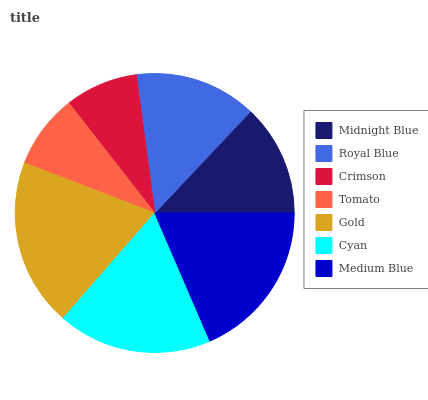Is Crimson the minimum?
Answer yes or no. Yes. Is Gold the maximum?
Answer yes or no. Yes. Is Royal Blue the minimum?
Answer yes or no. No. Is Royal Blue the maximum?
Answer yes or no. No. Is Royal Blue greater than Midnight Blue?
Answer yes or no. Yes. Is Midnight Blue less than Royal Blue?
Answer yes or no. Yes. Is Midnight Blue greater than Royal Blue?
Answer yes or no. No. Is Royal Blue less than Midnight Blue?
Answer yes or no. No. Is Royal Blue the high median?
Answer yes or no. Yes. Is Royal Blue the low median?
Answer yes or no. Yes. Is Medium Blue the high median?
Answer yes or no. No. Is Gold the low median?
Answer yes or no. No. 